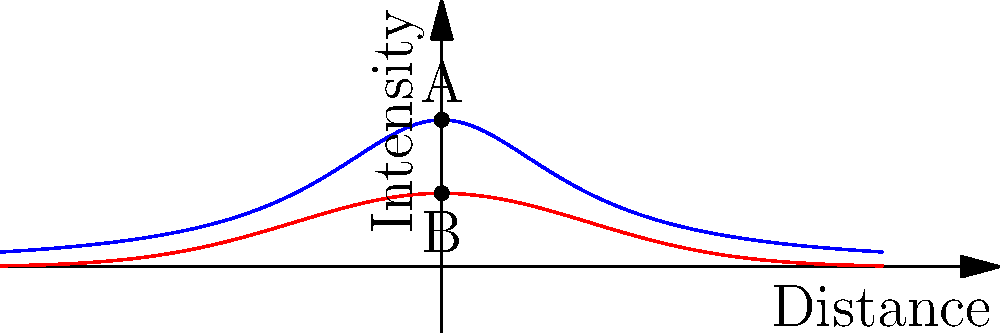In the context of non-Euclidean geometry applied to disease spread, consider the graph above where the blue curve represents the curvature of space-time and the red curve represents the pattern of disease spread. If point A represents the epicenter of an outbreak in curved space-time and point B represents the same location in flat space-time, how would you explain the difference in disease spread intensity to donors? To explain the difference in disease spread intensity to donors, we need to follow these steps:

1. Understand the graph:
   - The blue curve represents the curvature of space-time
   - The red curve represents the pattern of disease spread
   - Point A is on the blue curve (curved space-time)
   - Point B is on the red curve (flat space-time)

2. Analyze the intensity difference:
   - At x = 0 (epicenter), the intensity in curved space-time (A) is higher than in flat space-time (B)
   - The intensity in curved space-time is approximately 1, while in flat space-time it's about 0.5

3. Interpret the implications:
   - In curved space-time, the disease spread is more concentrated at the epicenter
   - This concentration leads to a higher intensity of cases in a smaller area

4. Explain the physical meaning:
   - The curvature of space-time affects how the disease spreads
   - It creates a "gravity well" effect, causing the disease to cluster more tightly

5. Compare to flat space-time:
   - In flat space-time, the disease spread is more uniform
   - This results in a lower peak intensity but potentially wider geographical spread

6. Relate to public health implications:
   - Higher intensity in curved space-time means more severe outbreaks in localized areas
   - This requires more concentrated resources and interventions at the epicenter
   - In flat space-time, resources might need to be distributed over a wider area

7. Quantify the difference:
   - The intensity at the epicenter in curved space-time is approximately twice that of flat space-time
   - This can be expressed mathematically as:
     $$\frac{Intensity_{curved}}{Intensity_{flat}} \approx \frac{1}{0.5} = 2$$

8. Conclude with the importance for donors:
   - Understanding this difference is crucial for allocating resources effectively
   - It highlights the need for flexible and adaptive response strategies
Answer: Curved space-time concentrates disease spread, doubling intensity at the epicenter compared to flat space-time, necessitating more focused interventions and resource allocation. 